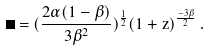<formula> <loc_0><loc_0><loc_500><loc_500>\Delta = ( \frac { 2 \alpha ( 1 - \beta ) } { 3 \beta ^ { 2 } } ) ^ { \frac { 1 } { 2 } } ( 1 + z ) ^ { \frac { - 3 \beta } { 2 } } \, .</formula> 